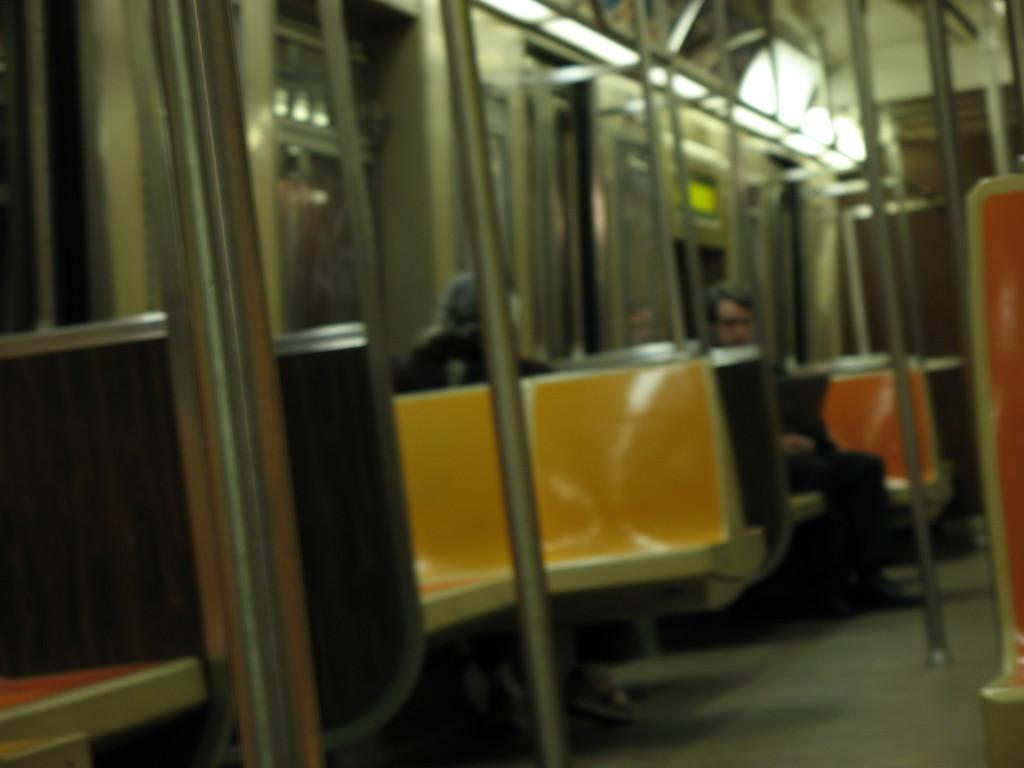What type of space is depicted in the image? The image shows the inside view of a vehicle. What can be seen inside the vehicle? There are people sitting in the vehicle, and there are seats, rods, glass objects, and lights visible. What might be used for support or stability in the vehicle? The rods in the vehicle might be used for support or stability. What surface is visible in the vehicle? There is a surface visible in the vehicle. What time of day is represented by the hour in the image? There is no hour present in the image, as it depicts the inside of a vehicle and not a clock or timepiece. 